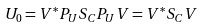<formula> <loc_0><loc_0><loc_500><loc_500>U _ { 0 } = V ^ { * } P _ { U } S _ { C } P _ { U } V = V ^ { * } S _ { C } V</formula> 